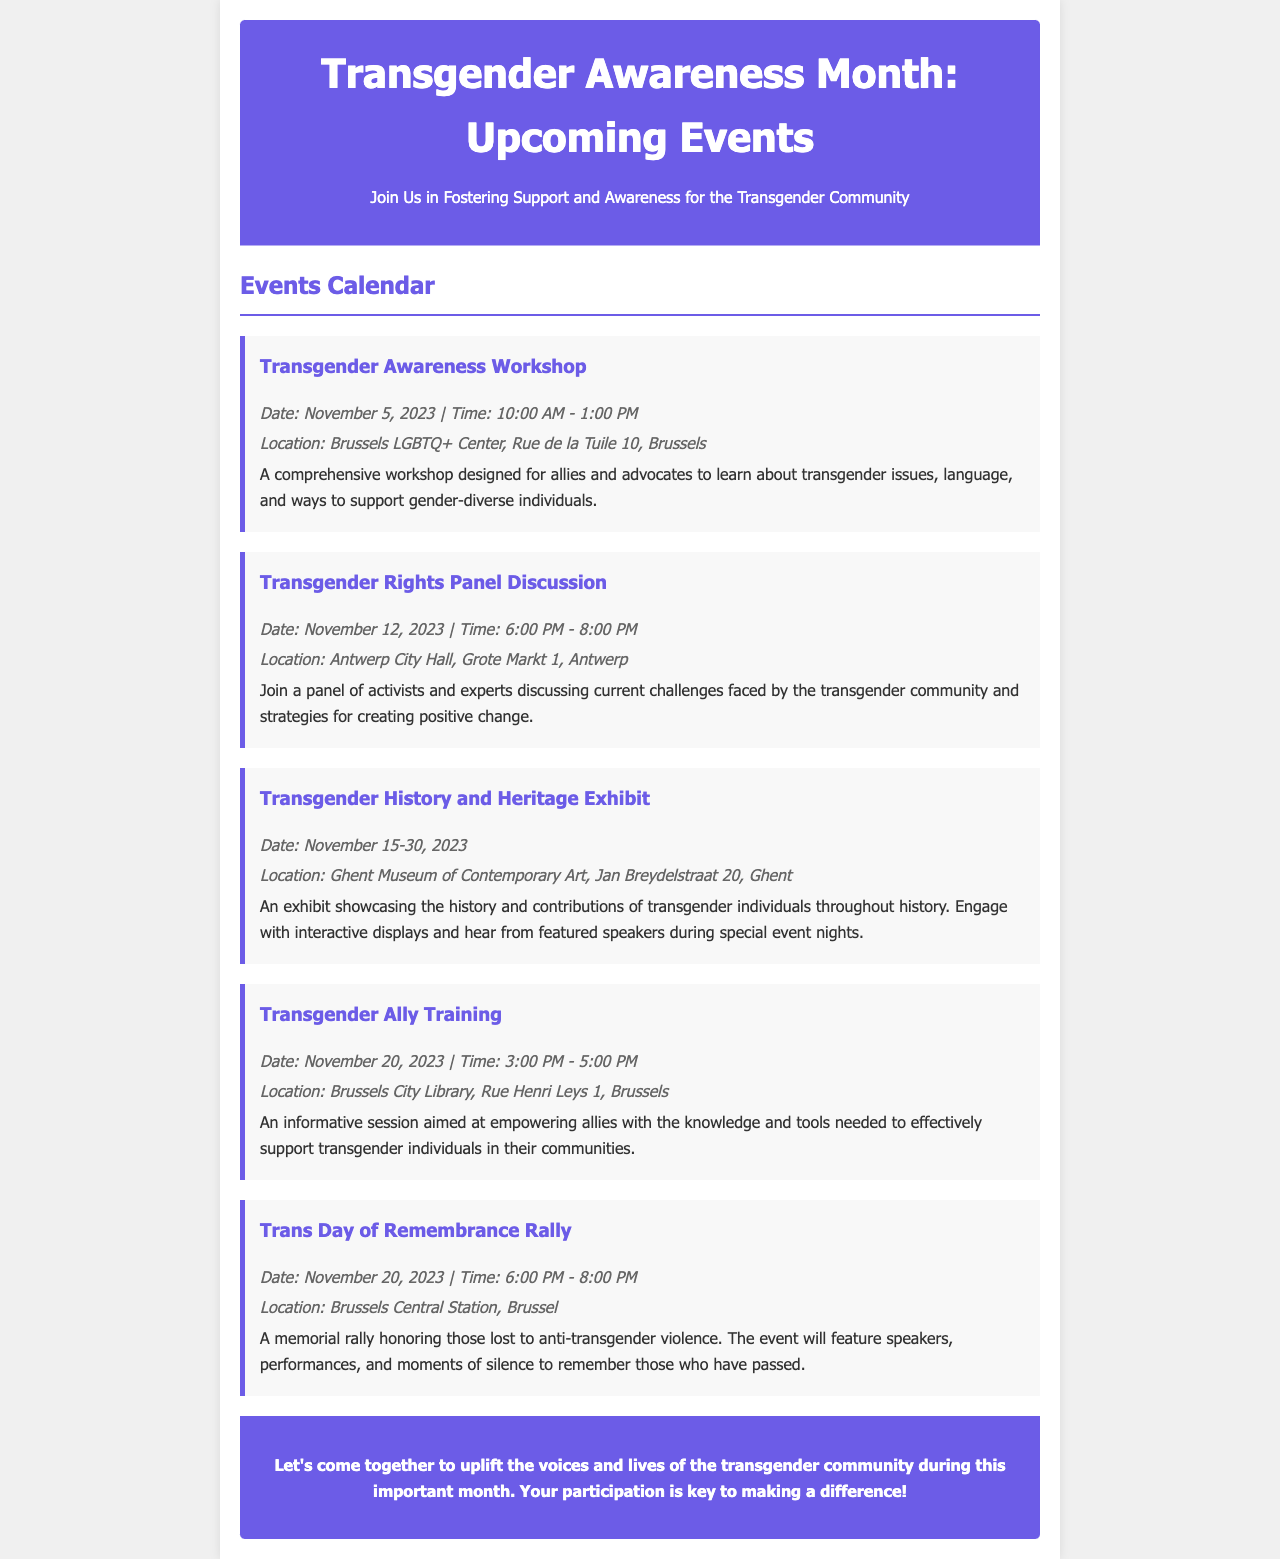what is the date of the Transgender Awareness Workshop? The date of the Transgender Awareness Workshop is stated in the document as November 5, 2023.
Answer: November 5, 2023 where is the Transgender Rights Panel Discussion taking place? The location for the Transgender Rights Panel Discussion is mentioned as Antwerp City Hall, Grote Markt 1, Antwerp.
Answer: Antwerp City Hall, Grote Markt 1, Antwerp how many days will the Transgender History and Heritage Exhibit run? The Transgender History and Heritage Exhibit runs from November 15 to November 30, 2023, totaling 16 days.
Answer: 16 days what is the time for the Transgender Ally Training? The document specifies that the time for the Transgender Ally Training is 3:00 PM to 5:00 PM.
Answer: 3:00 PM - 5:00 PM what is the purpose of the Trans Day of Remembrance Rally? The purpose of the Trans Day of Remembrance Rally is to honor those lost to anti-transgender violence, as stated in the document.
Answer: Honor those lost to anti-transgender violence how many events are listed in the document? The document lists five events throughout the month for Transgender Awareness Month.
Answer: Five events which event focuses on training allies? The event dedicated to training allies is the Transgender Ally Training mentioned in the document.
Answer: Transgender Ally Training who are the featured participants in the Transgender Rights Panel Discussion? The participants in the Transgender Rights Panel Discussion are activists and experts, as described in the document.
Answer: Activists and experts what is the theme for the newsletter? The overarching theme of the newsletter is fostering support and awareness for the transgender community during Transgender Awareness Month.
Answer: Fostering support and awareness 